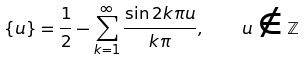Convert formula to latex. <formula><loc_0><loc_0><loc_500><loc_500>\{ u \} = \frac { 1 } { 2 } - \sum _ { k = 1 } ^ { \infty } \frac { \sin 2 k \pi u } { k \pi } , \quad u \notin \mathbb { Z }</formula> 